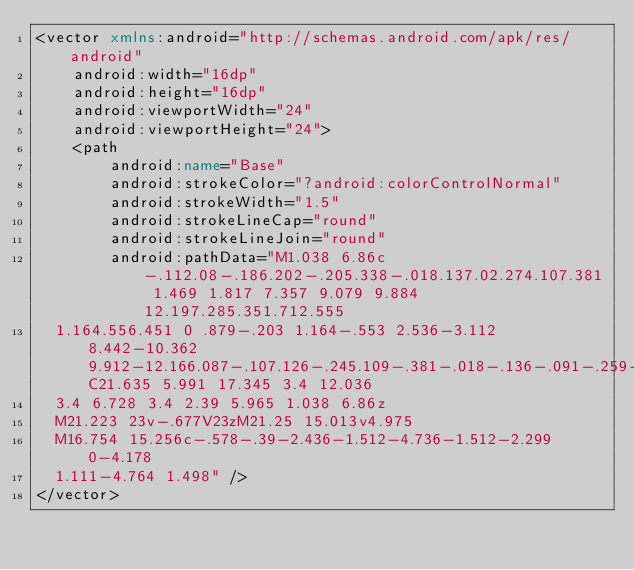Convert code to text. <code><loc_0><loc_0><loc_500><loc_500><_XML_><vector xmlns:android="http://schemas.android.com/apk/res/android"
    android:width="16dp"
    android:height="16dp"
    android:viewportWidth="24"
    android:viewportHeight="24">
    <path
        android:name="Base"
        android:strokeColor="?android:colorControlNormal"
        android:strokeWidth="1.5"
        android:strokeLineCap="round"
        android:strokeLineJoin="round"
        android:pathData="M1.038 6.86c-.112.08-.186.202-.205.338-.018.137.02.274.107.381 1.469 1.817 7.357 9.079 9.884 12.197.285.351.712.555
  1.164.556.451 0 .879-.203 1.164-.553 2.536-3.112 8.442-10.362 9.912-12.166.087-.107.126-.245.109-.381-.018-.136-.091-.259-.202-.34C21.635 5.991 17.345 3.4 12.036
  3.4 6.728 3.4 2.39 5.965 1.038 6.86z
  M21.223 23v-.677V23zM21.25 15.013v4.975
  M16.754 15.256c-.578-.39-2.436-1.512-4.736-1.512-2.299 0-4.178
  1.111-4.764 1.498" />
</vector></code> 